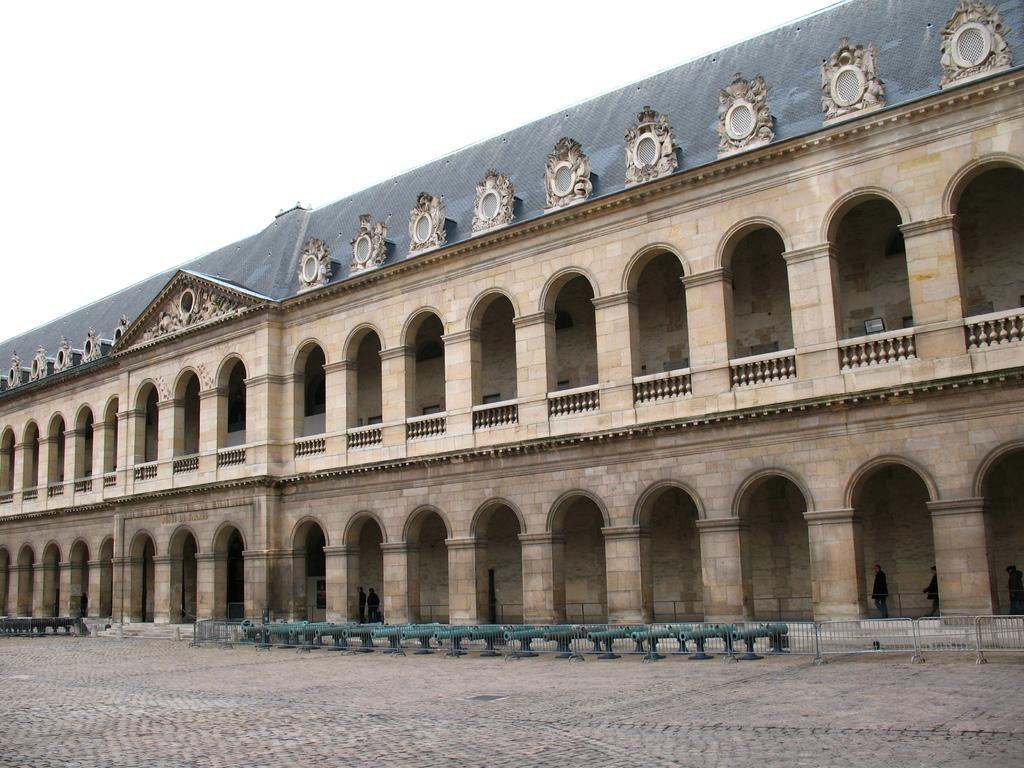What can be seen at the bottom of the image? The ground is visible at the bottom of the image. What is the main structure in the middle of the image? There is a building in the middle of the image. What architectural feature is present on the building? The building has pillars. What is visible at the top of the image? The sky is visible at the top of the image. Reasoning: Let' Let's think step by step in order to produce the conversation. We start by identifying the main subjects and objects in the image based on the provided facts. We then formulate questions that focus on the location and characteristics of these subjects and objects, ensuring that each question can be answered definitively with the information given. We avoid yes/no questions and ensure that the language is simple and clear. Absurd Question/Answer: What type of stitch is used to hold the building together in the image? There is no mention of stitching in the image; the building is held together by its construction materials and design. Can you tell me how many sisters are standing in front of the building in the image? There is no mention of any people, let alone sisters, in the image. What color is the dress worn by the person standing next to the building in the image? There is no person or dress present in the image; it only features a building with pillars. 